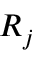Convert formula to latex. <formula><loc_0><loc_0><loc_500><loc_500>R _ { j }</formula> 